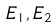Convert formula to latex. <formula><loc_0><loc_0><loc_500><loc_500>E _ { 1 } , E _ { 2 }</formula> 